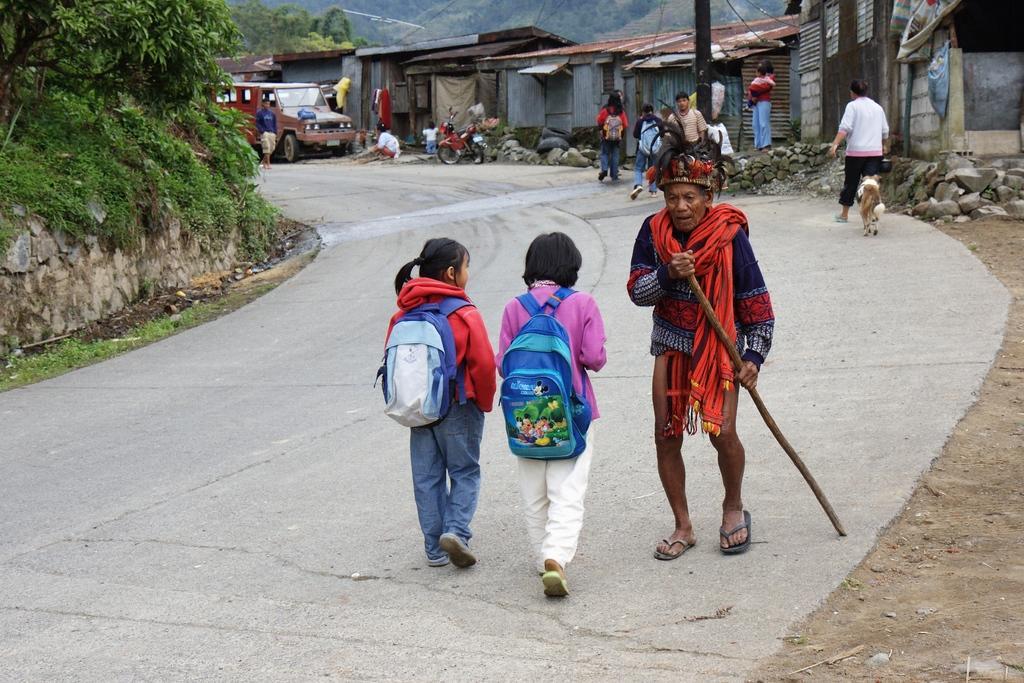Please provide a concise description of this image. In the center of the image we can see three persons are walking and they are in different costumes. Among them, we can see one person is holding some object and two persons are wearing bags. In the background, we can see trees, houses, rocks, vehicles, one dog, few people and a few other objects. 